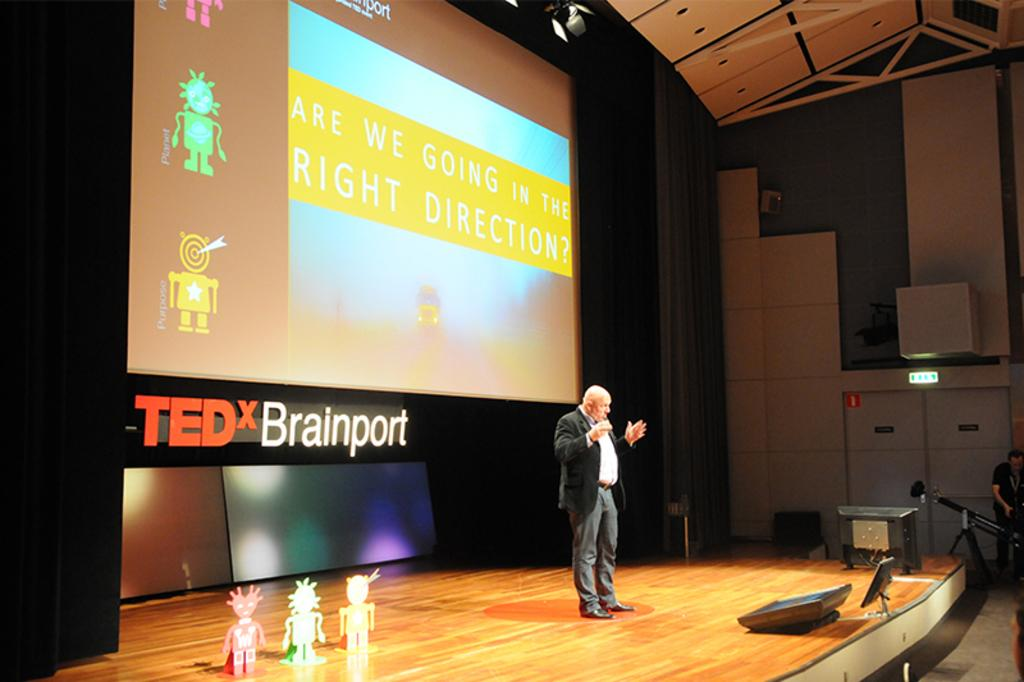Provide a one-sentence caption for the provided image. A man standing on a state speaking to an audience at Tedx brainport. 